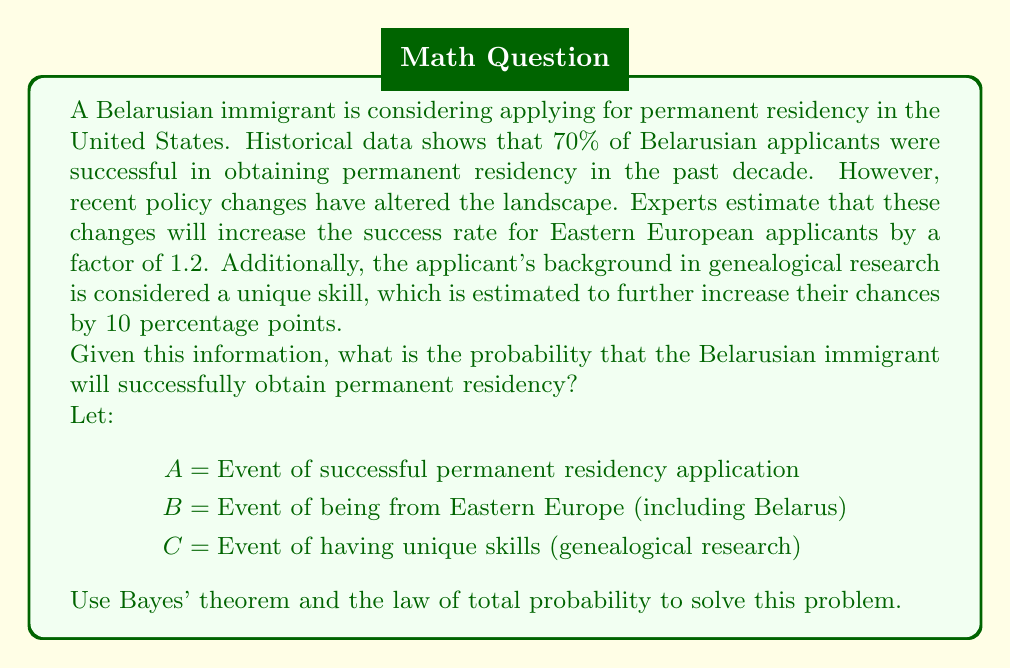Give your solution to this math problem. To solve this problem, we'll use Bayes' theorem and the law of total probability. Let's break it down step by step:

1) First, we need to calculate the updated probability of success for Eastern European applicants after the policy changes:

   $P(A|B) = 0.70 \times 1.2 = 0.84$

2) Now, we need to account for the additional increase due to unique skills:

   $P(A|B,C) = P(A|B) + 0.10 = 0.84 + 0.10 = 0.94$

3) We can use the law of total probability to calculate the final probability:

   $P(A) = P(A|B,C) \times P(B) \times P(C) + P(A|B,\overline{C}) \times P(B) \times P(\overline{C}) + P(A|\overline{B}) \times P(\overline{B})$

4) We know $P(A|B,C) = 0.94$ and $P(B) = 1$ (the applicant is definitely from Belarus). We don't have information about $P(C)$, $P(A|B,\overline{C})$, or $P(A|\overline{B})$, but we don't need them because $P(B) = 1$, which simplifies our equation:

   $P(A) = P(A|B,C) \times P(C) + P(A|B,\overline{C}) \times P(\overline{C})$

5) We still don't know $P(C)$, but we can calculate $P(A|B,\overline{C})$:

   $P(A|B,\overline{C}) = 0.84$ (this is the probability without the unique skills boost)

6) Let $x = P(C)$. Then $P(\overline{C}) = 1 - x$

7) Substituting into our equation:

   $P(A) = 0.94x + 0.84(1-x) = 0.94x + 0.84 - 0.84x = 0.84 + 0.10x$

8) This final equation gives us the probability of success based on the probability of having unique skills. Since we don't know the exact value of $x$, we can say that the probability of success is between 0.84 (when $x = 0$) and 0.94 (when $x = 1$).
Answer: The probability that the Belarusian immigrant will successfully obtain permanent residency is $0.84 + 0.10x$, where $x$ is the probability of the applicant being considered to have unique skills. This probability ranges from 0.84 to 0.94, depending on how likely the applicant's genealogical research skills are to be considered unique. 